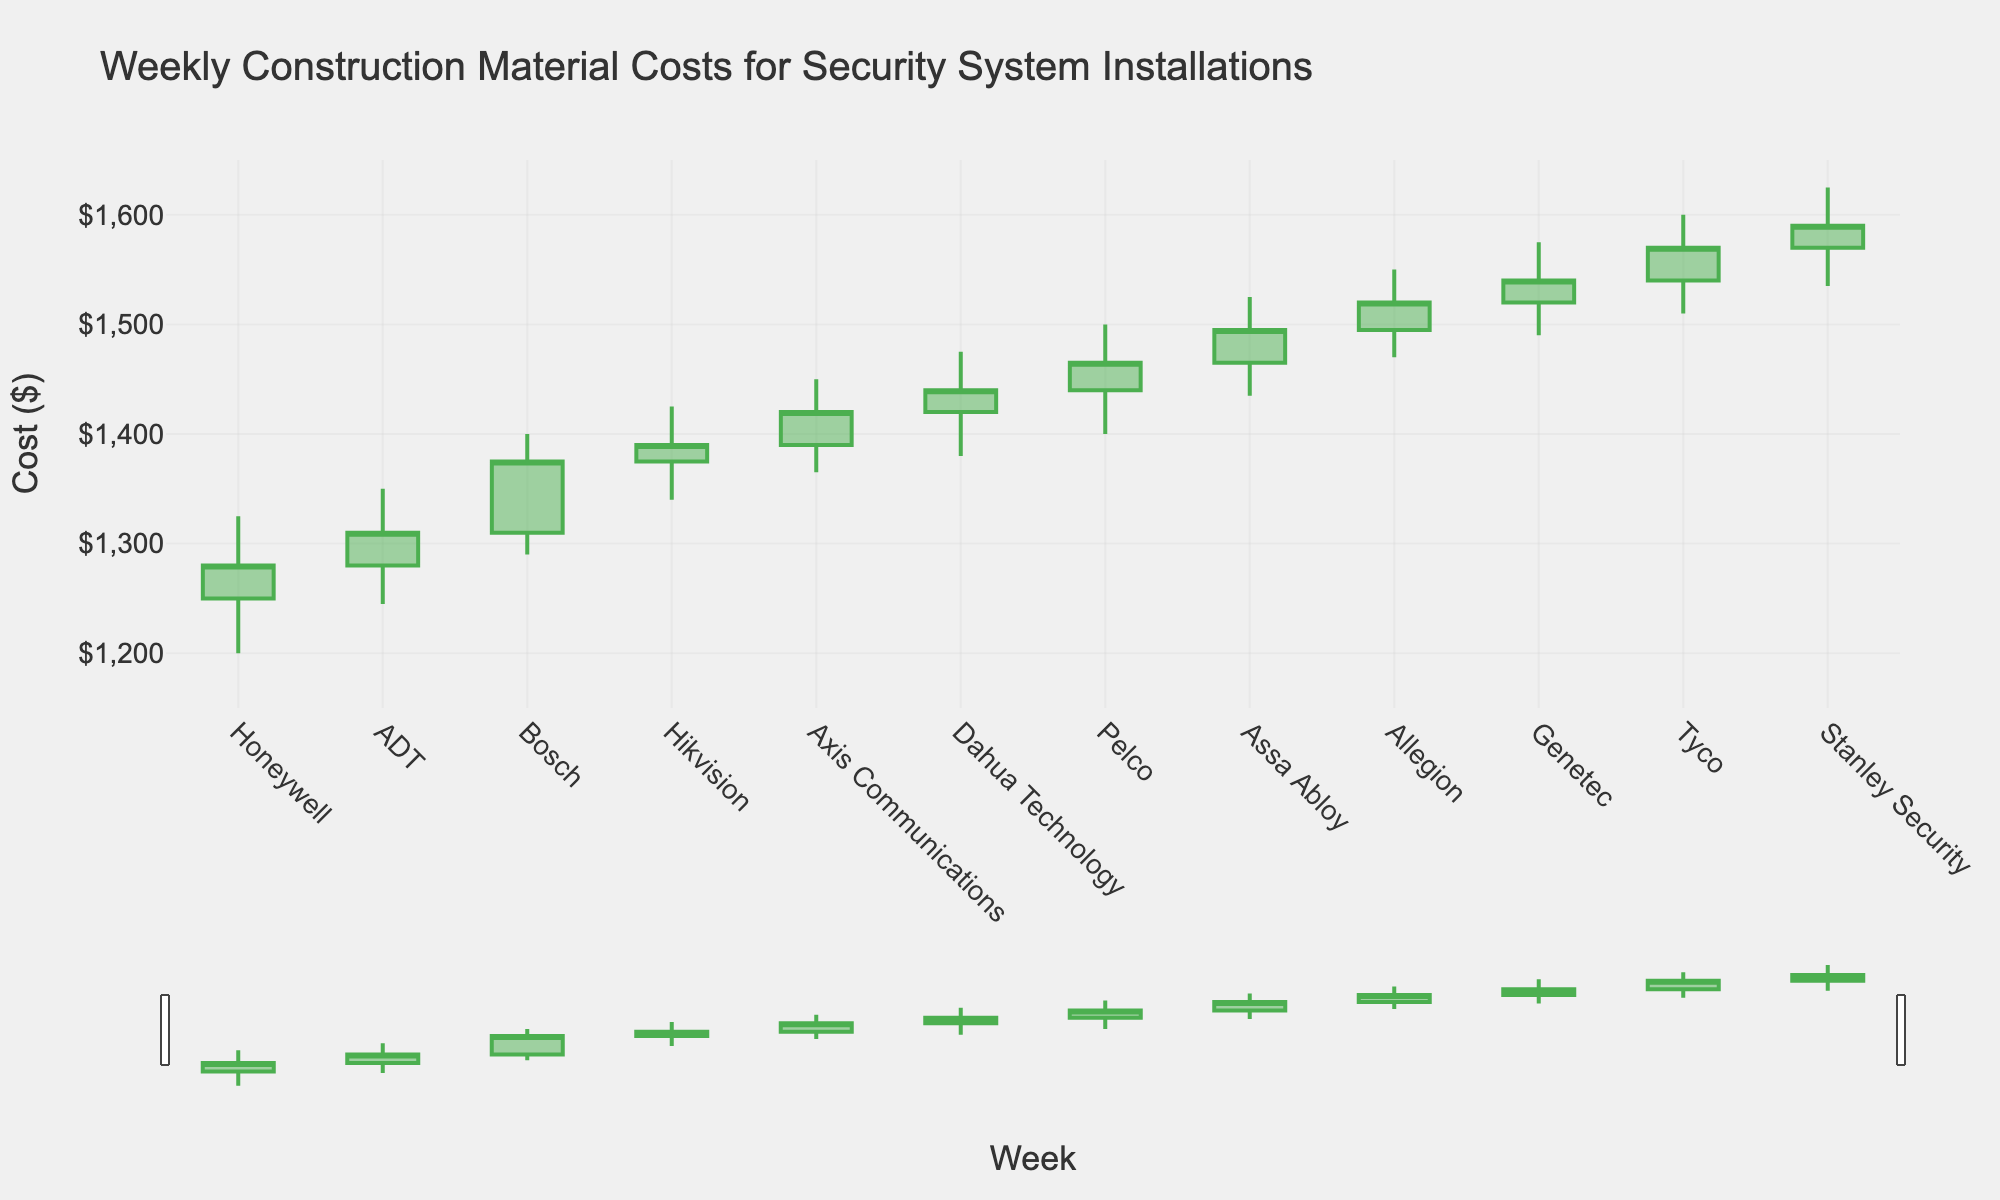What is the title of the figure? The title is displayed at the top of the figure and reads "Weekly Construction Material Costs for Security System Installations."
Answer: Weekly Construction Material Costs for Security System Installations Which week had the highest closing cost? By evaluating the closing costs for each week, Week 11 had the highest closing cost at $1570.
Answer: Week 11 How are the colors used to indicate increasing and decreasing costs? The colors used in the figure for increasing costs are green, and for decreasing costs are red.
Answer: Green for increasing, red for decreasing What is the range of the y-axis? The y-axis range is marked from the minimum value to the maximum, which is between $1150 and $1650.
Answer: $1150 to $1650 In which week did the cost have the largest spread (High-Low)? The week with the largest spread can be calculated by subtracting the lowest from the highest for each week. Week 3 had a high of $1400 and a low of $1290, making the spread $110.
Answer: Week 3 What is the difference between the opening cost of Week 5 and Week 10? To find the difference, subtract the opening cost of Week 5 ($1390) from the opening cost of Week 10 ($1520), resulting in $130.
Answer: $130 Which supplier had the lowest low value? Reviewing the data for the lowest value in each week, Honeywell in Week 1 had a low of $1200, which is the lowest.
Answer: Honeywell How many weeks displayed an increase in the closing cost compared to the opening cost? By comparing the closing and opening costs for each week, we find that Week 3, Week 4, Week 5, Week 6, Week 7, Week 8, Week 9, Week 10, Week 11, and Week 12 had increases in the closing cost. That's 10 out of 12 weeks.
Answer: 10 weeks What was the closing cost in Week 8? By looking at Week 8 in the data, the closing cost is indicated as $1495.
Answer: $1495 Between which two consecutive weeks was the closing cost change the largest? Analyzing the change in closing costs between consecutive weeks, the largest change is between Week 11 and Week 12. The Closing cost was $1590 in Week 12 compared to $1570 in Week 11, a difference of $20.
Answer: Between Week 11 and Week 12 